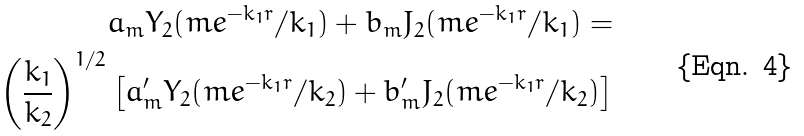<formula> <loc_0><loc_0><loc_500><loc_500>a _ { m } Y _ { 2 } ( m e ^ { - k _ { 1 } r } / k _ { 1 } ) + b _ { m } J _ { 2 } ( m e ^ { - k _ { 1 } r } / k _ { 1 } ) = \\ \left ( \frac { k _ { 1 } } { k _ { 2 } } \right ) ^ { 1 / 2 } \left [ a ^ { \prime } _ { m } Y _ { 2 } ( m e ^ { - k _ { 1 } r } / k _ { 2 } ) + b ^ { \prime } _ { m } J _ { 2 } ( m e ^ { - k _ { 1 } r } / k _ { 2 } ) \right ]</formula> 